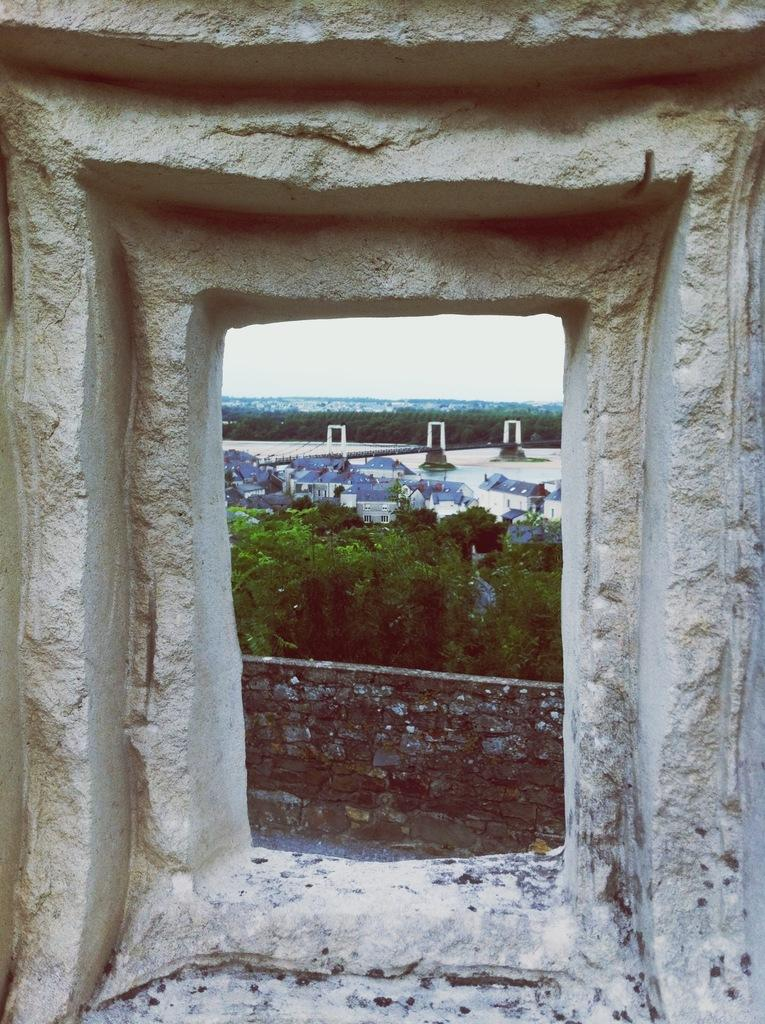What is located in the foreground of the image? There is a window in the foreground of the image. What can be seen in the background of the image? There are houses, trees, and the sky visible in the background of the image. What type of grain is being harvested in the image? There is no grain or harvesting activity present in the image. Is there any evidence of war or conflict in the image? There is no indication of war or conflict in the image. 